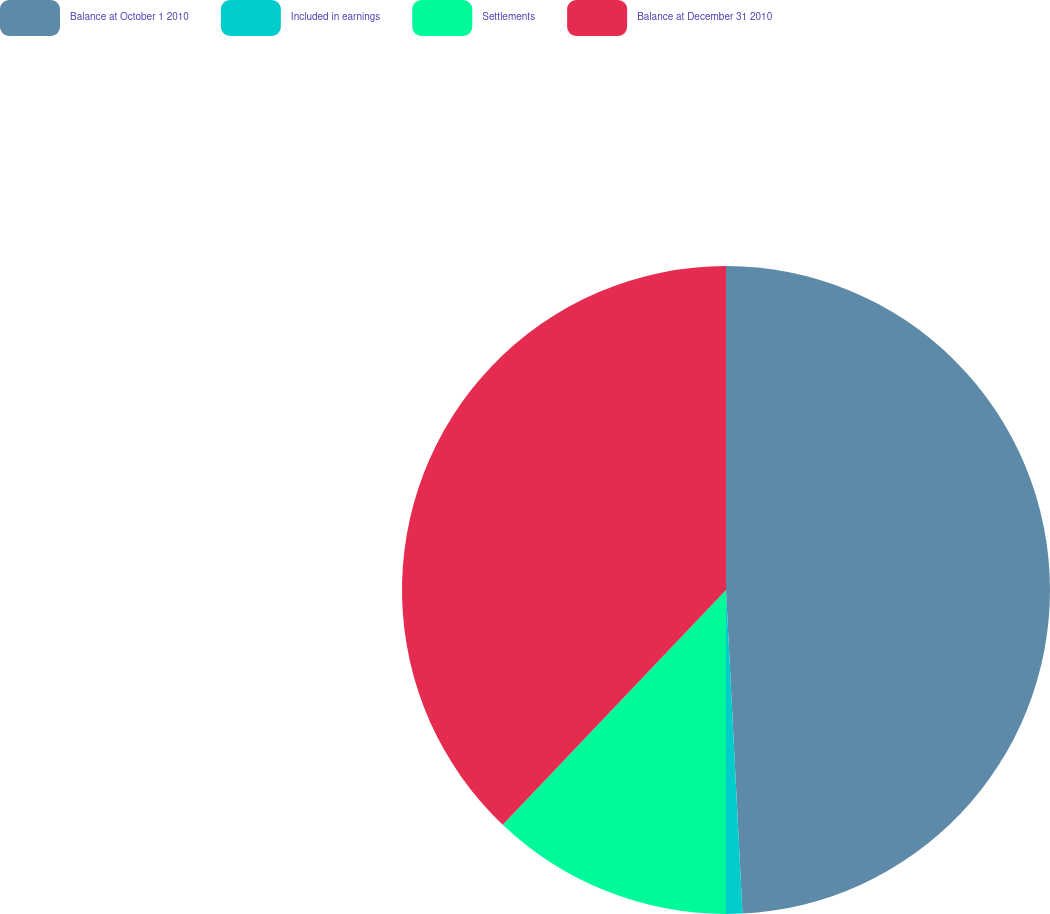Convert chart to OTSL. <chart><loc_0><loc_0><loc_500><loc_500><pie_chart><fcel>Balance at October 1 2010<fcel>Included in earnings<fcel>Settlements<fcel>Balance at December 31 2010<nl><fcel>49.19%<fcel>0.81%<fcel>12.1%<fcel>37.9%<nl></chart> 